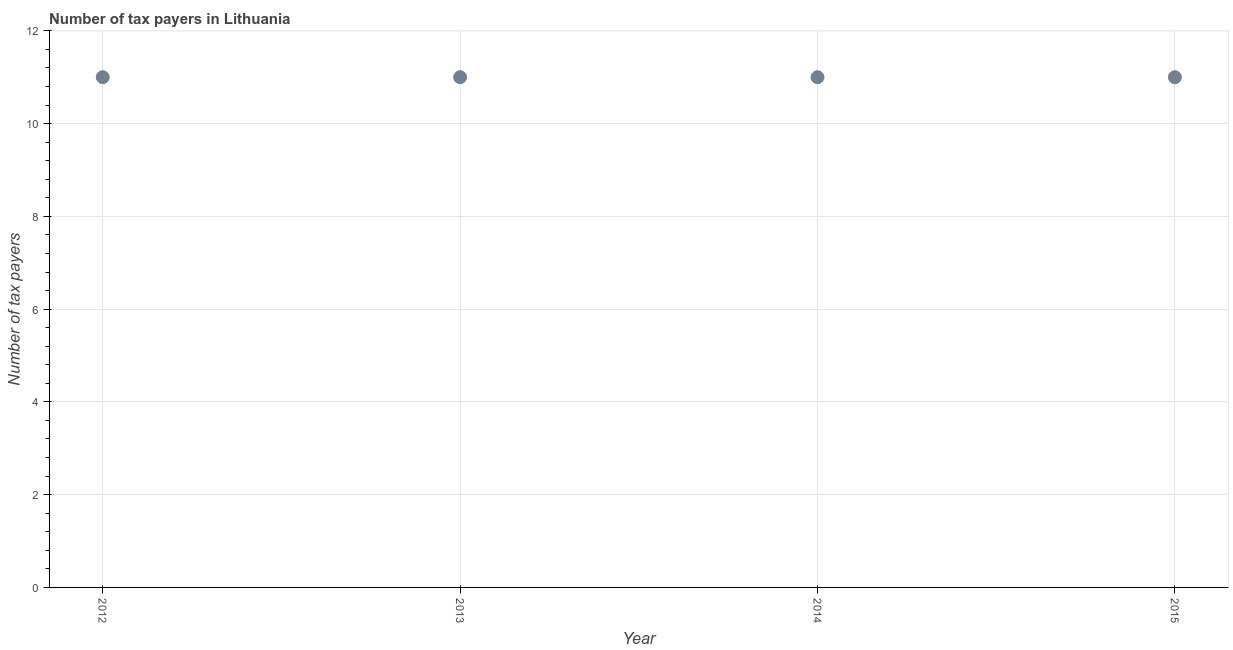What is the number of tax payers in 2014?
Your answer should be compact. 11. Across all years, what is the maximum number of tax payers?
Provide a succinct answer. 11. Across all years, what is the minimum number of tax payers?
Make the answer very short. 11. In which year was the number of tax payers maximum?
Offer a terse response. 2012. What is the sum of the number of tax payers?
Your response must be concise. 44. What is the difference between the number of tax payers in 2013 and 2014?
Offer a very short reply. 0. What is the ratio of the number of tax payers in 2013 to that in 2015?
Provide a short and direct response. 1. What is the difference between the highest and the second highest number of tax payers?
Offer a very short reply. 0. What is the difference between the highest and the lowest number of tax payers?
Give a very brief answer. 0. How many years are there in the graph?
Offer a very short reply. 4. What is the difference between two consecutive major ticks on the Y-axis?
Give a very brief answer. 2. Does the graph contain grids?
Provide a short and direct response. Yes. What is the title of the graph?
Ensure brevity in your answer.  Number of tax payers in Lithuania. What is the label or title of the X-axis?
Keep it short and to the point. Year. What is the label or title of the Y-axis?
Offer a terse response. Number of tax payers. What is the Number of tax payers in 2015?
Keep it short and to the point. 11. What is the difference between the Number of tax payers in 2012 and 2013?
Provide a short and direct response. 0. What is the difference between the Number of tax payers in 2012 and 2014?
Your answer should be very brief. 0. What is the difference between the Number of tax payers in 2012 and 2015?
Offer a very short reply. 0. What is the difference between the Number of tax payers in 2014 and 2015?
Your answer should be compact. 0. What is the ratio of the Number of tax payers in 2012 to that in 2013?
Your response must be concise. 1. 